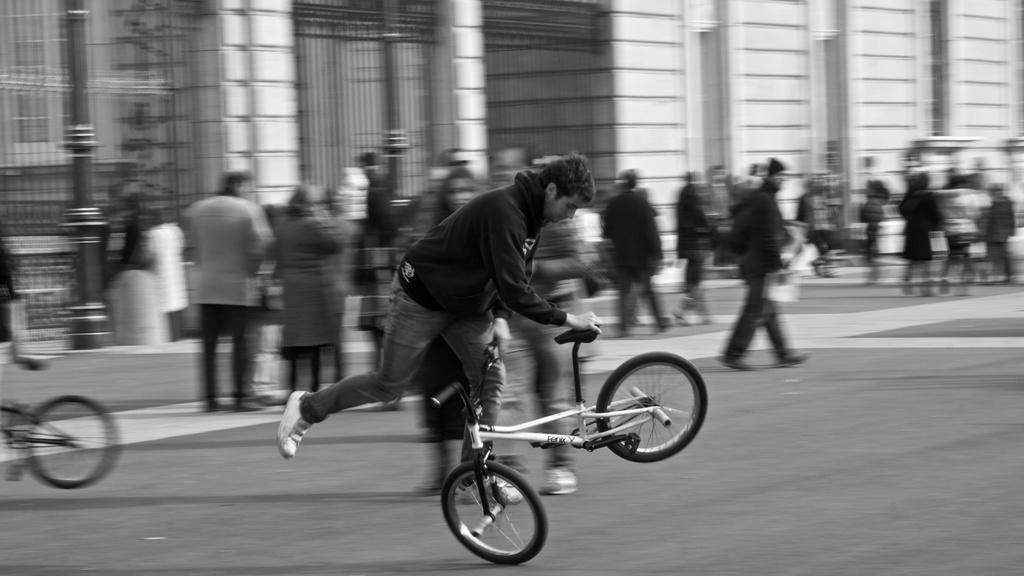How would you summarize this image in a sentence or two? A man is playing with a small bicycle on a road. There are some people walking behind him. 